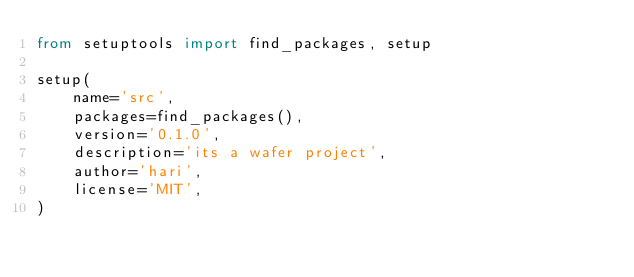Convert code to text. <code><loc_0><loc_0><loc_500><loc_500><_Python_>from setuptools import find_packages, setup

setup(
    name='src',
    packages=find_packages(),
    version='0.1.0',
    description='its a wafer project',
    author='hari',
    license='MIT',
)
</code> 